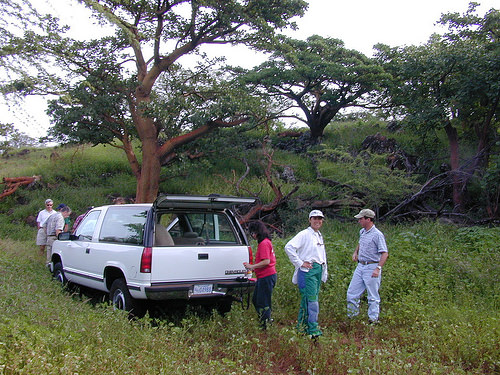<image>
Is the tree on the car? No. The tree is not positioned on the car. They may be near each other, but the tree is not supported by or resting on top of the car. 